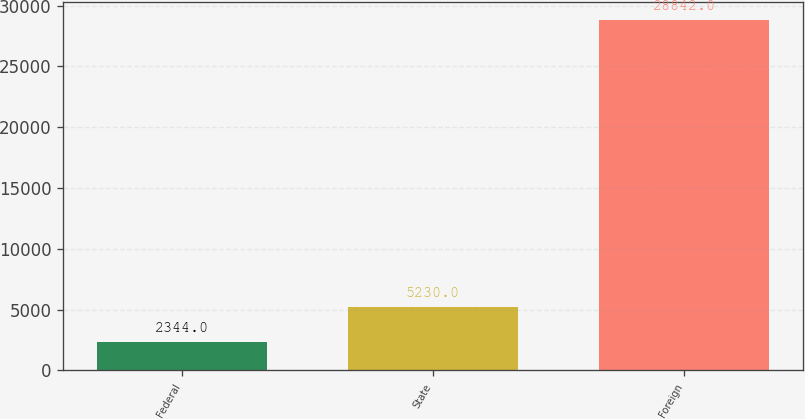Convert chart to OTSL. <chart><loc_0><loc_0><loc_500><loc_500><bar_chart><fcel>Federal<fcel>State<fcel>Foreign<nl><fcel>2344<fcel>5230<fcel>28842<nl></chart> 